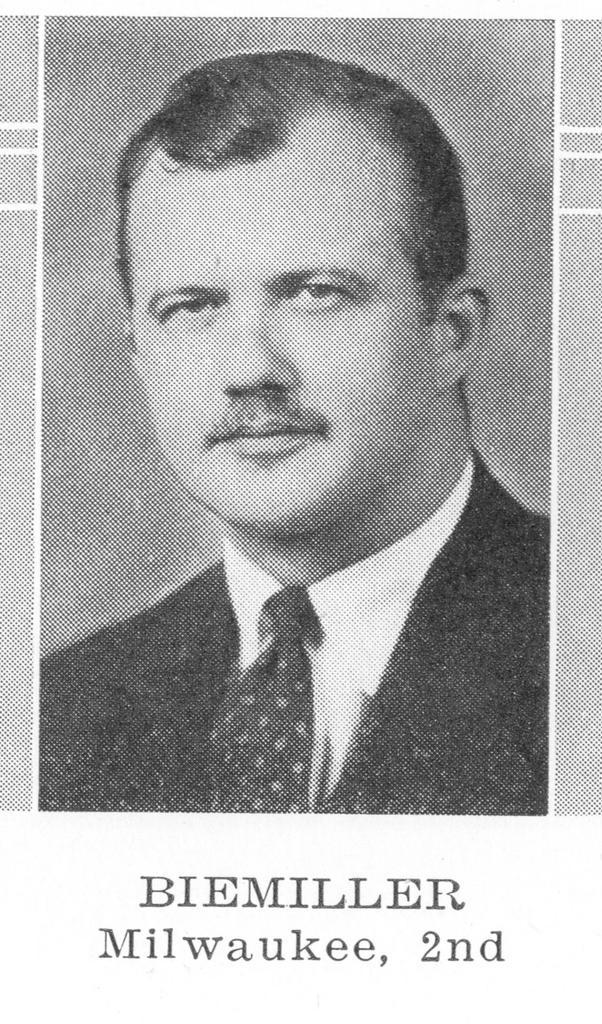How would you summarize this image in a sentence or two? In this picture there is a man wearing a coat and Tie and there is some text written on it. 